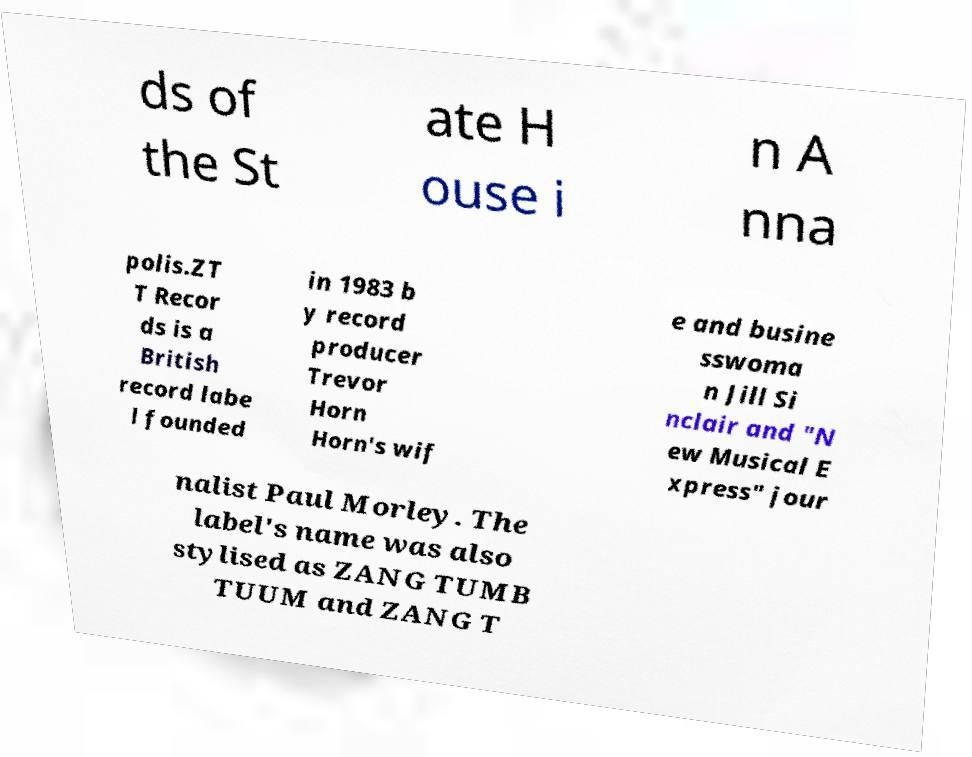There's text embedded in this image that I need extracted. Can you transcribe it verbatim? ds of the St ate H ouse i n A nna polis.ZT T Recor ds is a British record labe l founded in 1983 b y record producer Trevor Horn Horn's wif e and busine sswoma n Jill Si nclair and "N ew Musical E xpress" jour nalist Paul Morley. The label's name was also stylised as ZANG TUMB TUUM and ZANG T 